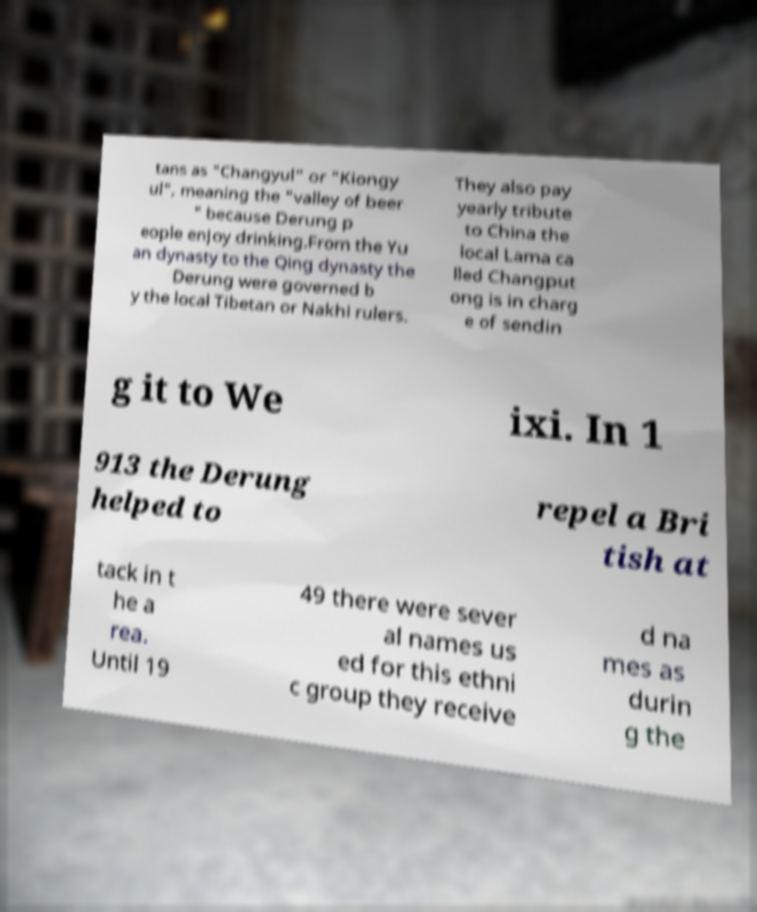Could you assist in decoding the text presented in this image and type it out clearly? tans as "Changyul" or "Kiongy ul", meaning the "valley of beer " because Derung p eople enjoy drinking.From the Yu an dynasty to the Qing dynasty the Derung were governed b y the local Tibetan or Nakhi rulers. They also pay yearly tribute to China the local Lama ca lled Changput ong is in charg e of sendin g it to We ixi. In 1 913 the Derung helped to repel a Bri tish at tack in t he a rea. Until 19 49 there were sever al names us ed for this ethni c group they receive d na mes as durin g the 